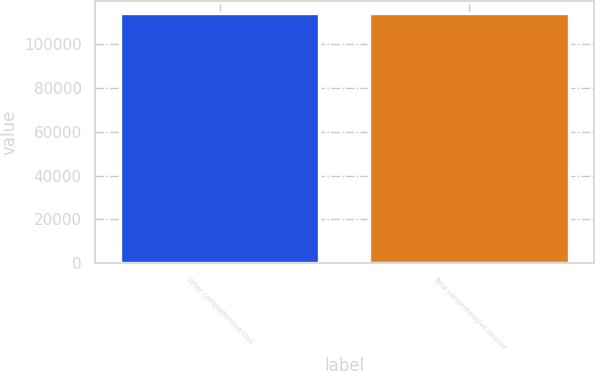Convert chart to OTSL. <chart><loc_0><loc_0><loc_500><loc_500><bar_chart><fcel>Other comprehensive loss<fcel>Total comprehensive income<nl><fcel>114184<fcel>114184<nl></chart> 